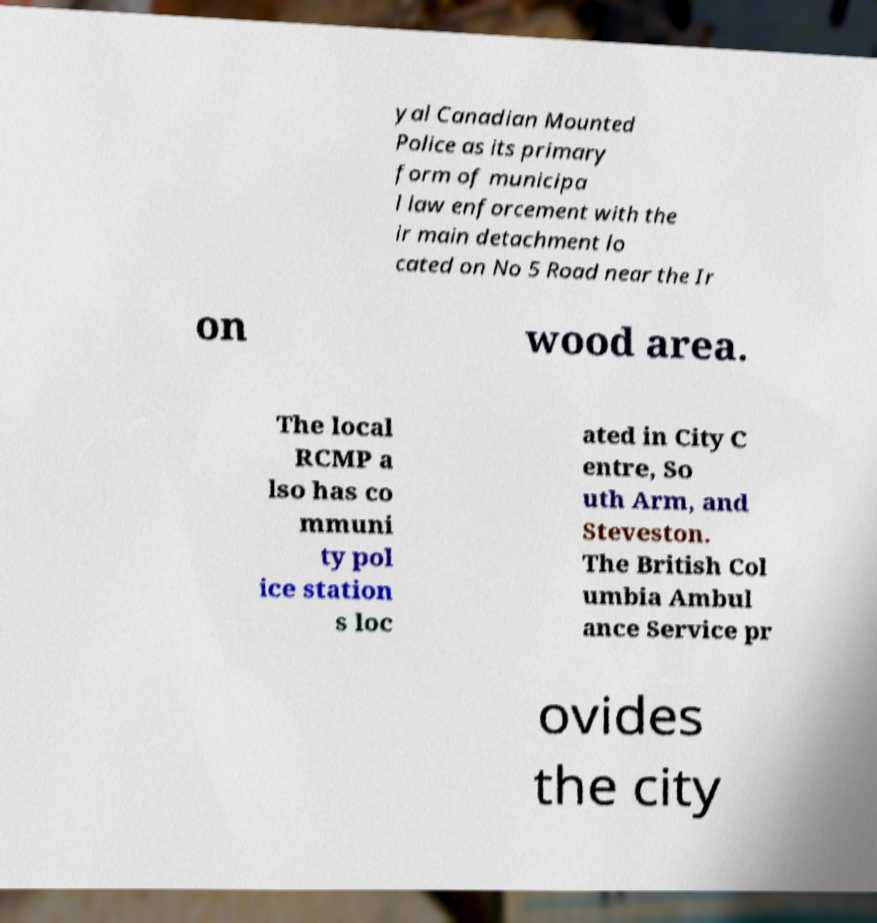Can you accurately transcribe the text from the provided image for me? yal Canadian Mounted Police as its primary form of municipa l law enforcement with the ir main detachment lo cated on No 5 Road near the Ir on wood area. The local RCMP a lso has co mmuni ty pol ice station s loc ated in City C entre, So uth Arm, and Steveston. The British Col umbia Ambul ance Service pr ovides the city 